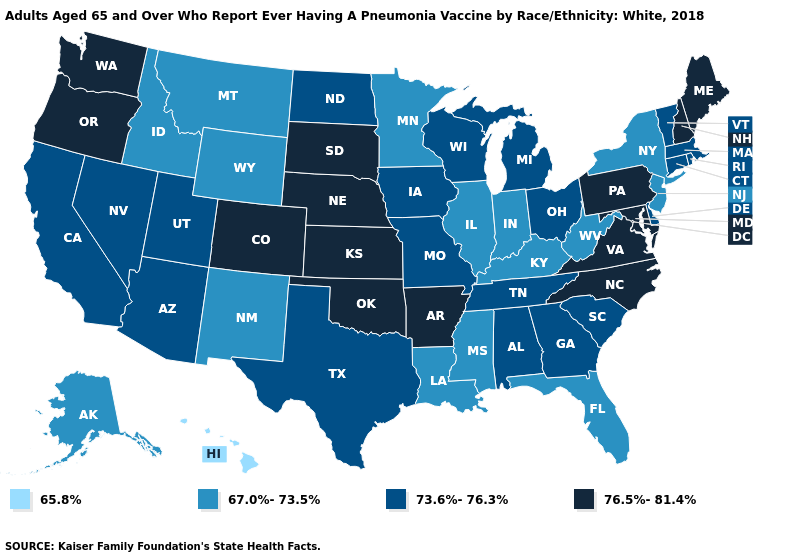What is the lowest value in states that border Nebraska?
Concise answer only. 67.0%-73.5%. Does Nebraska have a lower value than Alabama?
Concise answer only. No. What is the value of Kansas?
Short answer required. 76.5%-81.4%. Name the states that have a value in the range 67.0%-73.5%?
Answer briefly. Alaska, Florida, Idaho, Illinois, Indiana, Kentucky, Louisiana, Minnesota, Mississippi, Montana, New Jersey, New Mexico, New York, West Virginia, Wyoming. Which states hav the highest value in the West?
Short answer required. Colorado, Oregon, Washington. Name the states that have a value in the range 65.8%?
Short answer required. Hawaii. Which states have the lowest value in the USA?
Quick response, please. Hawaii. Name the states that have a value in the range 76.5%-81.4%?
Quick response, please. Arkansas, Colorado, Kansas, Maine, Maryland, Nebraska, New Hampshire, North Carolina, Oklahoma, Oregon, Pennsylvania, South Dakota, Virginia, Washington. Does North Carolina have the highest value in the South?
Give a very brief answer. Yes. Name the states that have a value in the range 76.5%-81.4%?
Concise answer only. Arkansas, Colorado, Kansas, Maine, Maryland, Nebraska, New Hampshire, North Carolina, Oklahoma, Oregon, Pennsylvania, South Dakota, Virginia, Washington. What is the lowest value in the USA?
Quick response, please. 65.8%. Does the map have missing data?
Keep it brief. No. What is the value of Kansas?
Be succinct. 76.5%-81.4%. Does Hawaii have the lowest value in the USA?
Answer briefly. Yes. Name the states that have a value in the range 65.8%?
Concise answer only. Hawaii. 